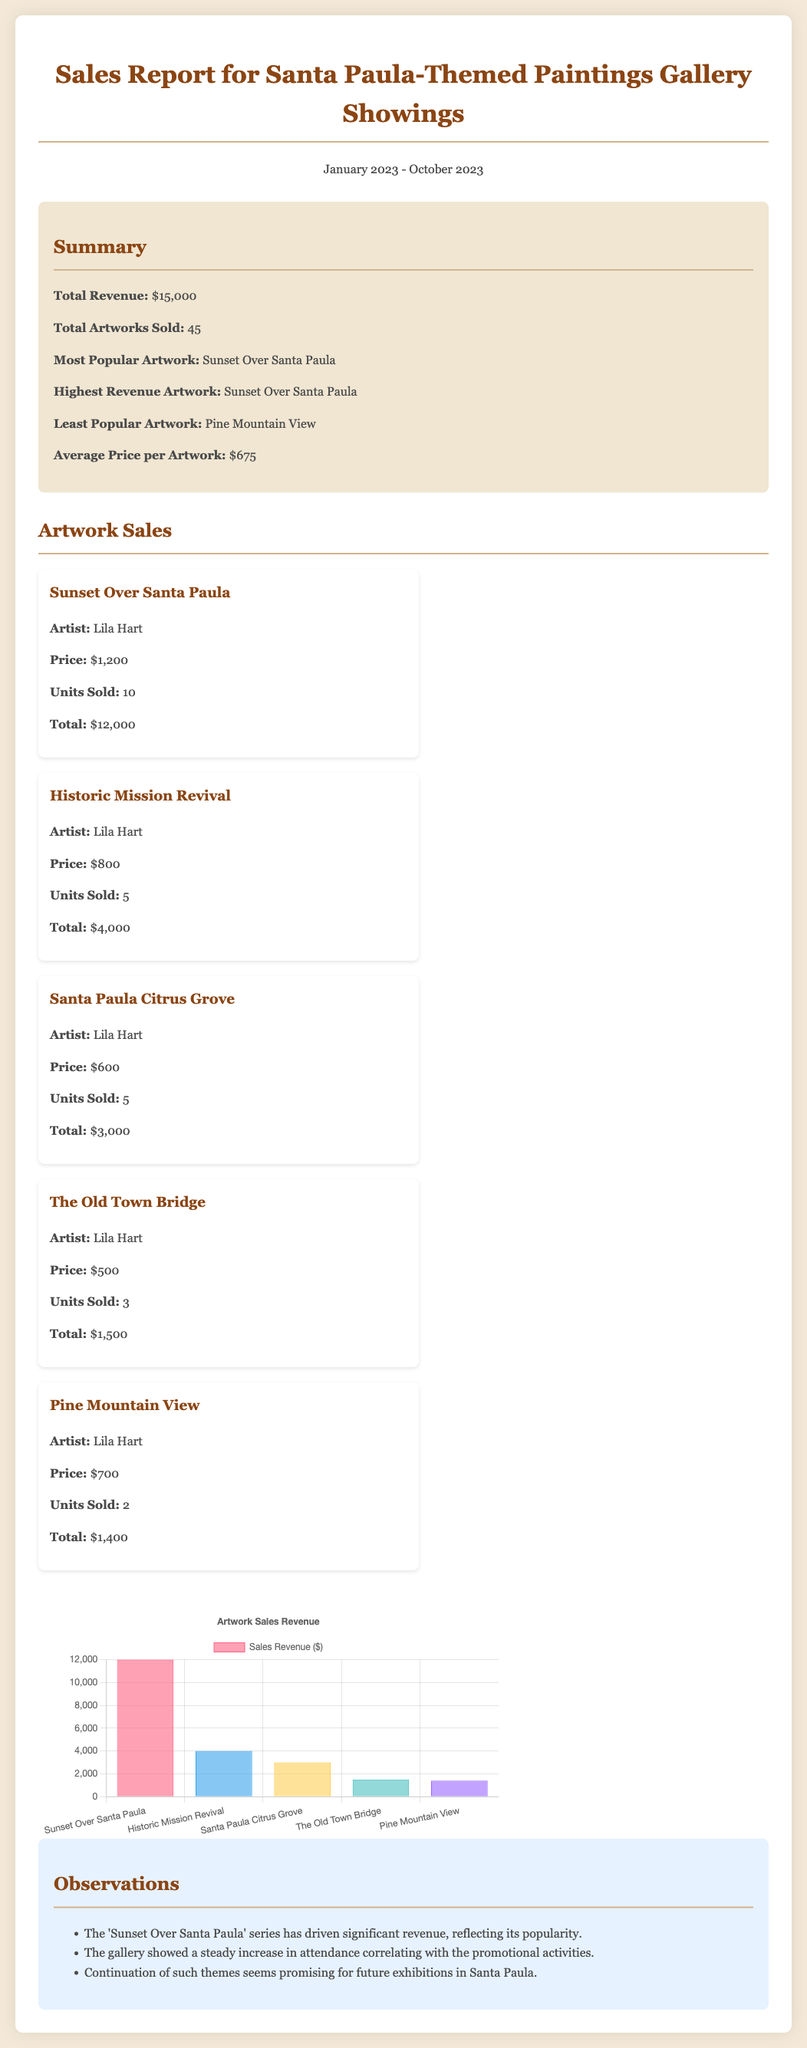What is the total revenue? The total revenue is explicitly stated in the summary section of the document, which totals $15,000.
Answer: $15,000 How many artworks were sold? The document notes the total number of artworks sold in the summary, which is 45.
Answer: 45 Which artwork had the highest sales? The summary highlights that "Sunset Over Santa Paula" is both the most popular and highest revenue artwork, indicating its success.
Answer: Sunset Over Santa Paula What was the average price per artwork? The average price is mentioned in the summary as $675, calculated from the total revenue divided by total artworks sold.
Answer: $675 How many units of "The Old Town Bridge" were sold? The sales details for "The Old Town Bridge" specify that 3 units were sold.
Answer: 3 What is the total revenue from "Historic Mission Revival"? The total from "Historic Mission Revival" is derived from the sales details indicating 5 units sold at $800 each, which totals $4,000.
Answer: $4,000 What is the least popular artwork? The summary identifies "Pine Mountain View" as the least popular artwork in the gallery showings.
Answer: Pine Mountain View How many artworks were sold for more than $1,000? By analyzing the sales details, only "Sunset Over Santa Paula" had a price above $1,000, hence 10 units were sold at that price.
Answer: 10 What is the total sales revenue for "Santa Paula Citrus Grove"? The sales details show that "Santa Paula Citrus Grove" had 5 units sold at $600 each, making a total of $3,000.
Answer: $3,000 